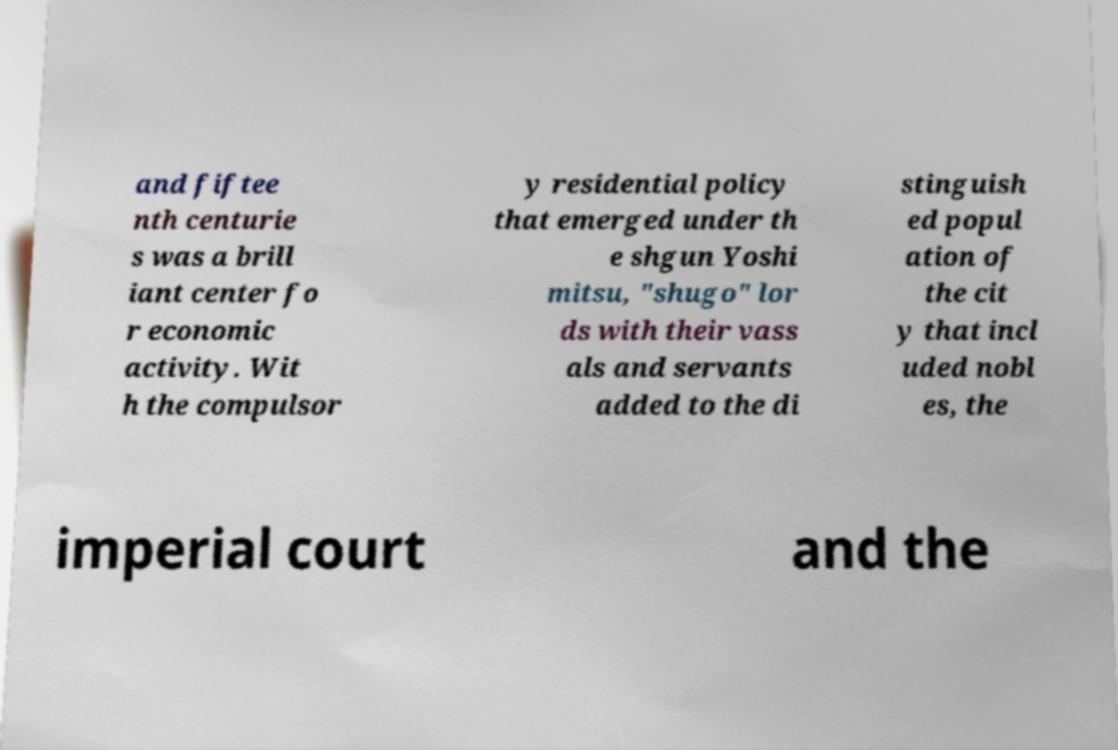I need the written content from this picture converted into text. Can you do that? and fiftee nth centurie s was a brill iant center fo r economic activity. Wit h the compulsor y residential policy that emerged under th e shgun Yoshi mitsu, "shugo" lor ds with their vass als and servants added to the di stinguish ed popul ation of the cit y that incl uded nobl es, the imperial court and the 